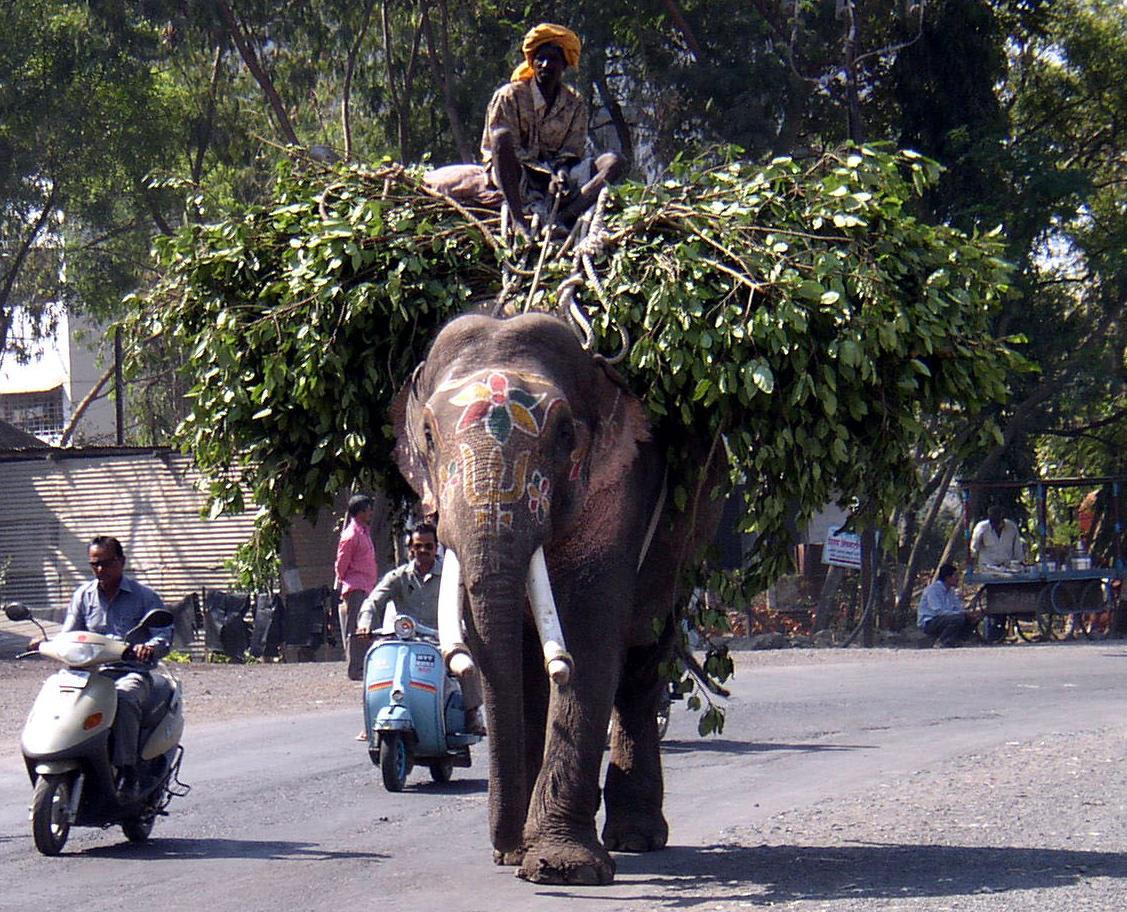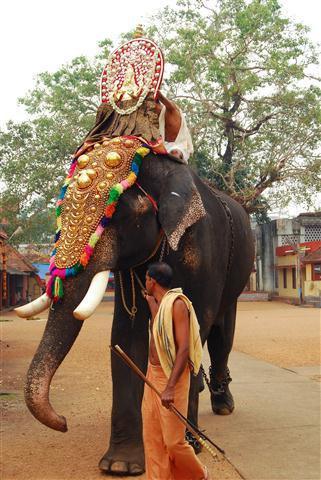The first image is the image on the left, the second image is the image on the right. Analyze the images presented: Is the assertion "At least one person is standing near an elephant in the image on the right." valid? Answer yes or no. Yes. The first image is the image on the left, the second image is the image on the right. For the images shown, is this caption "One elephant wears primarily orange decorations and has something trimmed with bell shapes around its neck." true? Answer yes or no. No. 